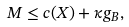<formula> <loc_0><loc_0><loc_500><loc_500>M \leq c ( X ) + \kappa g _ { B } ,</formula> 